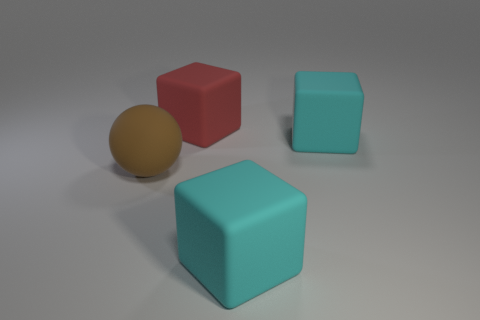Do the large red object and the big brown object have the same shape?
Provide a short and direct response. No. How many objects are cyan rubber things behind the big brown ball or small cylinders?
Ensure brevity in your answer.  1. Are there any other things that have the same shape as the red object?
Offer a very short reply. Yes. Is the number of red rubber things that are behind the rubber ball the same as the number of large cyan matte objects?
Your answer should be very brief. No. How many red cubes are the same size as the brown rubber thing?
Your answer should be compact. 1. How many red rubber cubes are on the right side of the large brown object?
Ensure brevity in your answer.  1. There is a large cyan thing that is to the right of the big cyan object in front of the large matte ball; what is it made of?
Give a very brief answer. Rubber. The brown ball that is made of the same material as the red block is what size?
Your answer should be very brief. Large. The object that is to the left of the large red matte object is what color?
Ensure brevity in your answer.  Brown. Is there a big cyan rubber object that is behind the big rubber thing in front of the thing to the left of the red block?
Keep it short and to the point. Yes. 